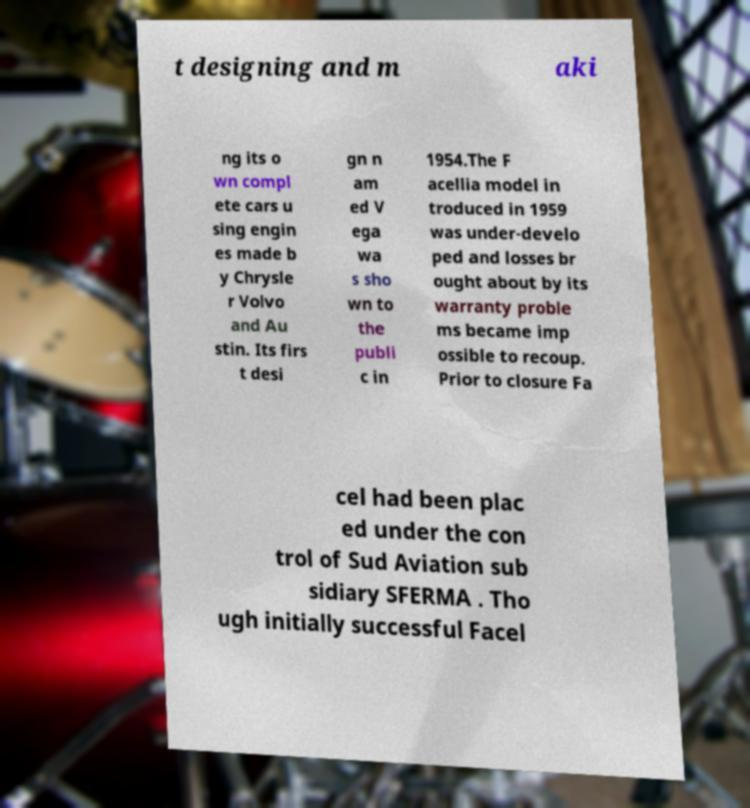Can you read and provide the text displayed in the image?This photo seems to have some interesting text. Can you extract and type it out for me? t designing and m aki ng its o wn compl ete cars u sing engin es made b y Chrysle r Volvo and Au stin. Its firs t desi gn n am ed V ega wa s sho wn to the publi c in 1954.The F acellia model in troduced in 1959 was under-develo ped and losses br ought about by its warranty proble ms became imp ossible to recoup. Prior to closure Fa cel had been plac ed under the con trol of Sud Aviation sub sidiary SFERMA . Tho ugh initially successful Facel 